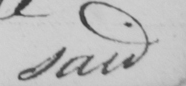Please transcribe the handwritten text in this image. said 